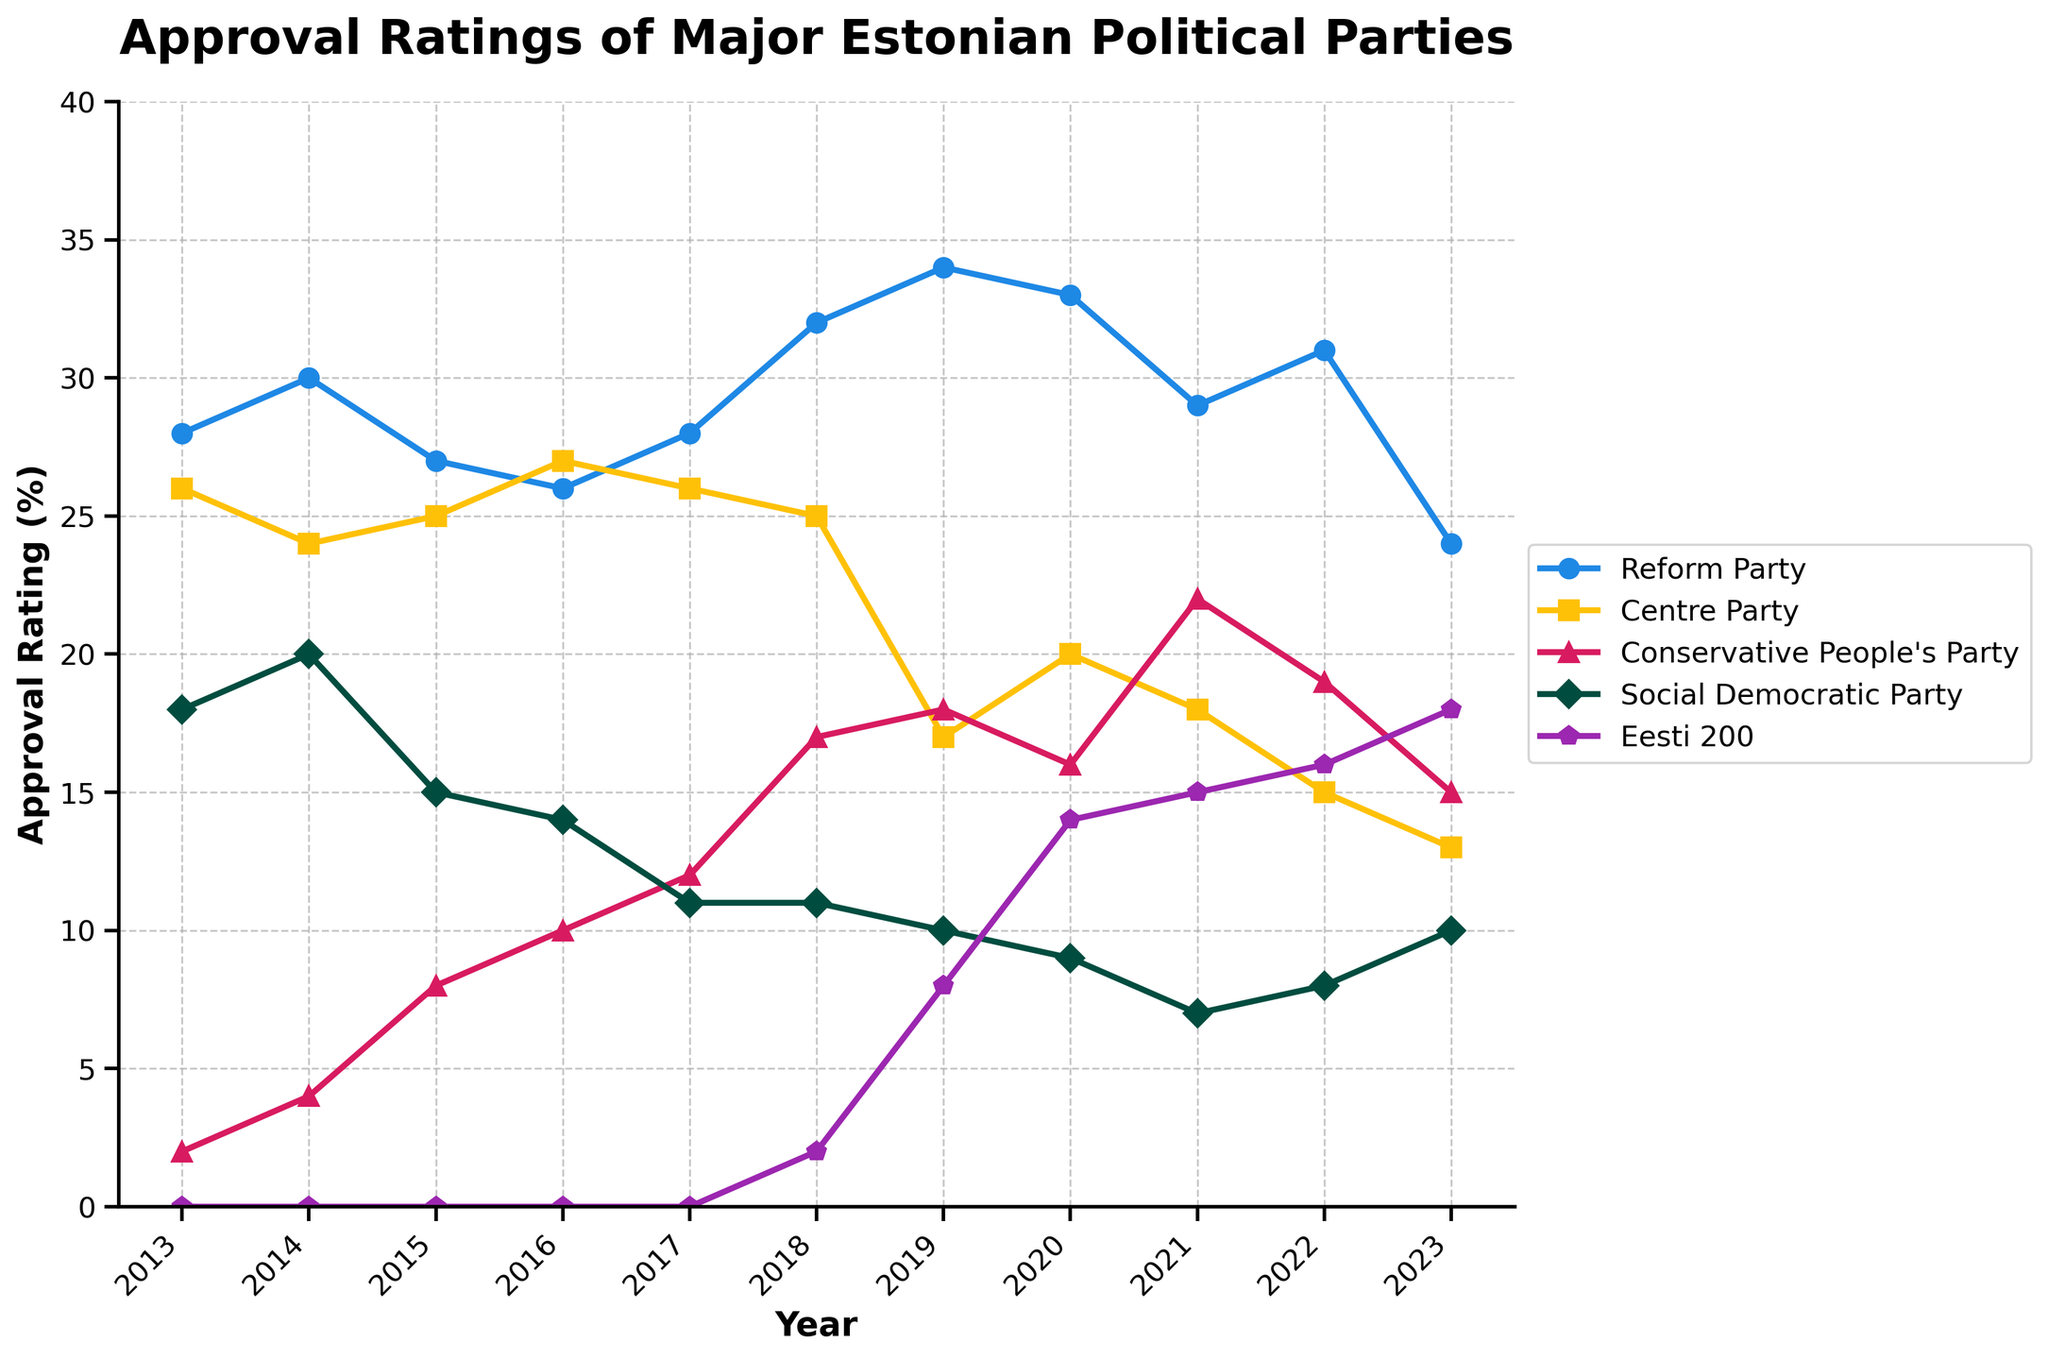What's the average approval rating of the Reform Party from 2013 to 2023? To calculate the average approval rating of the Reform Party, sum the yearly ratings: 28 + 30 + 27 + 26 + 28 + 32 + 34 + 33 + 29 + 31 + 24 = 322. There are 11 years, so divide the total by 11: 322 / 11 = 29.27
Answer: 29.27 Which party had the highest rating in 2019? In the figure for 2019, the highest approval rating belongs to the Reform Party with 34%. Check the year 2019 along the x-axis and compare all parties' ratings, noting the highest value.
Answer: Reform Party Between 2016 and 2017, which party had the greatest increase in approval rating? Looking at the change from 2016 to 2017: the Reform Party moved from 26% to 28% (+2%), the Centre Party from 27% to 26% (-1%), the Conservative People's Party from 10% to 12% (+2%), the Social Democratic Party from 14% to 11% (-3%), and Eesti 200 was not present. Both the Reform Party and the Conservative People's Party increased by 2%. Therefore, it's a tie.
Answer: Reform Party, Conservative People's Party (tie) How many parties had an approval rating of 10% or higher in 2023? In 2023, check each party's rating: Reform Party (24%), Centre Party (13%), Conservative People's Party (15%), Social Democratic Party (10%), and Eesti 200 (18%). All five parties had ratings of 10% or above.
Answer: 5 Which party had the lowest rating in 2020? For the year 2020, identify the lowest percentage. Reform Party (33%), Centre Party (20%), Conservative People's Party (16%), Social Democratic Party (9%), and Eesti 200 (14%). The Social Democratic Party had the lowest rating at 9%.
Answer: Social Democratic Party In which year did the Centre Party have its highest approval rating? Examine the Centre Party's ratings across all years: The maximum value is 27%, occurring in 2016.
Answer: 2016 Compare the approval ratings of the Conservative People's Party in 2014 and 2022. Which year had a higher rating and by how much? The Conservative People's Party had a rating of 4% in 2014 and 19% in 2022. The difference is: 19% - 4% = 15%. 2022 had a higher rating by 15%.
Answer: 2022 by 15% What was the approval rating trend of the Social Democratic Party from 2013 to 2023? Observing the Social Democratic Party's ratings: 18% (2013), 20% (2014), 15% (2015), 14% (2016), 11% (2017), 11% (2018), 10% (2019), 9% (2020), 7% (2021), 8% (2022), 10% (2023). The trend shows a general decline from 2013 to 2021, with a slight increase from 2021 onwards.
Answer: Declining trend till 2021, slight increase afterward What is the total increase in the approval rating of Eesti 200 from 2018 to 2023? Eesti 200's rating started from 2% in 2018 and increased to 18% in 2023. The total increase is: 18% - 2% = 16%.
Answer: 16% 